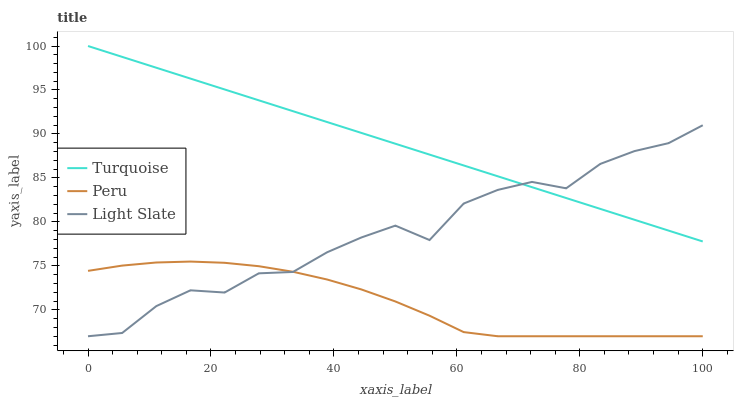Does Peru have the minimum area under the curve?
Answer yes or no. Yes. Does Turquoise have the maximum area under the curve?
Answer yes or no. Yes. Does Turquoise have the minimum area under the curve?
Answer yes or no. No. Does Peru have the maximum area under the curve?
Answer yes or no. No. Is Turquoise the smoothest?
Answer yes or no. Yes. Is Light Slate the roughest?
Answer yes or no. Yes. Is Peru the smoothest?
Answer yes or no. No. Is Peru the roughest?
Answer yes or no. No. Does Light Slate have the lowest value?
Answer yes or no. Yes. Does Turquoise have the lowest value?
Answer yes or no. No. Does Turquoise have the highest value?
Answer yes or no. Yes. Does Peru have the highest value?
Answer yes or no. No. Is Peru less than Turquoise?
Answer yes or no. Yes. Is Turquoise greater than Peru?
Answer yes or no. Yes. Does Light Slate intersect Peru?
Answer yes or no. Yes. Is Light Slate less than Peru?
Answer yes or no. No. Is Light Slate greater than Peru?
Answer yes or no. No. Does Peru intersect Turquoise?
Answer yes or no. No. 